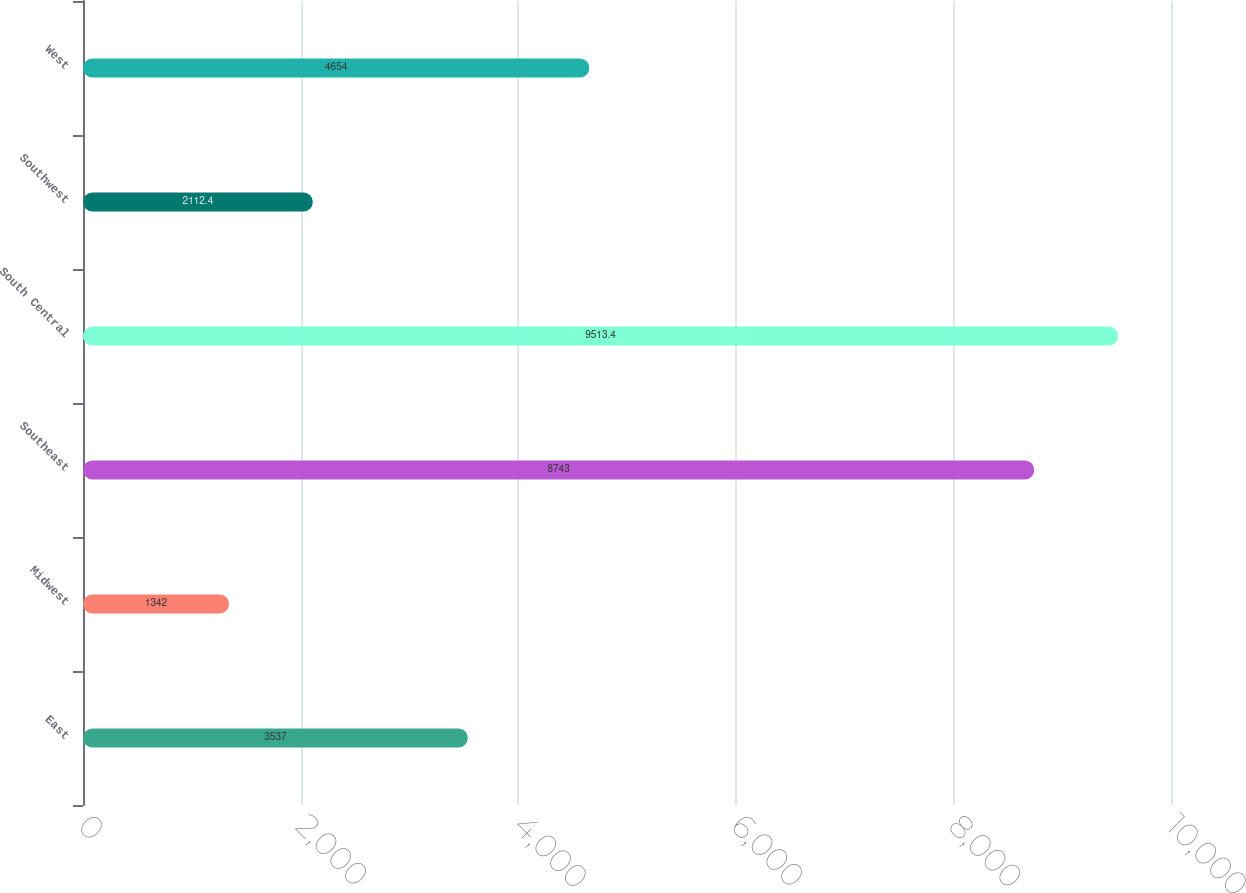Convert chart. <chart><loc_0><loc_0><loc_500><loc_500><bar_chart><fcel>East<fcel>Midwest<fcel>Southeast<fcel>South Central<fcel>Southwest<fcel>West<nl><fcel>3537<fcel>1342<fcel>8743<fcel>9513.4<fcel>2112.4<fcel>4654<nl></chart> 